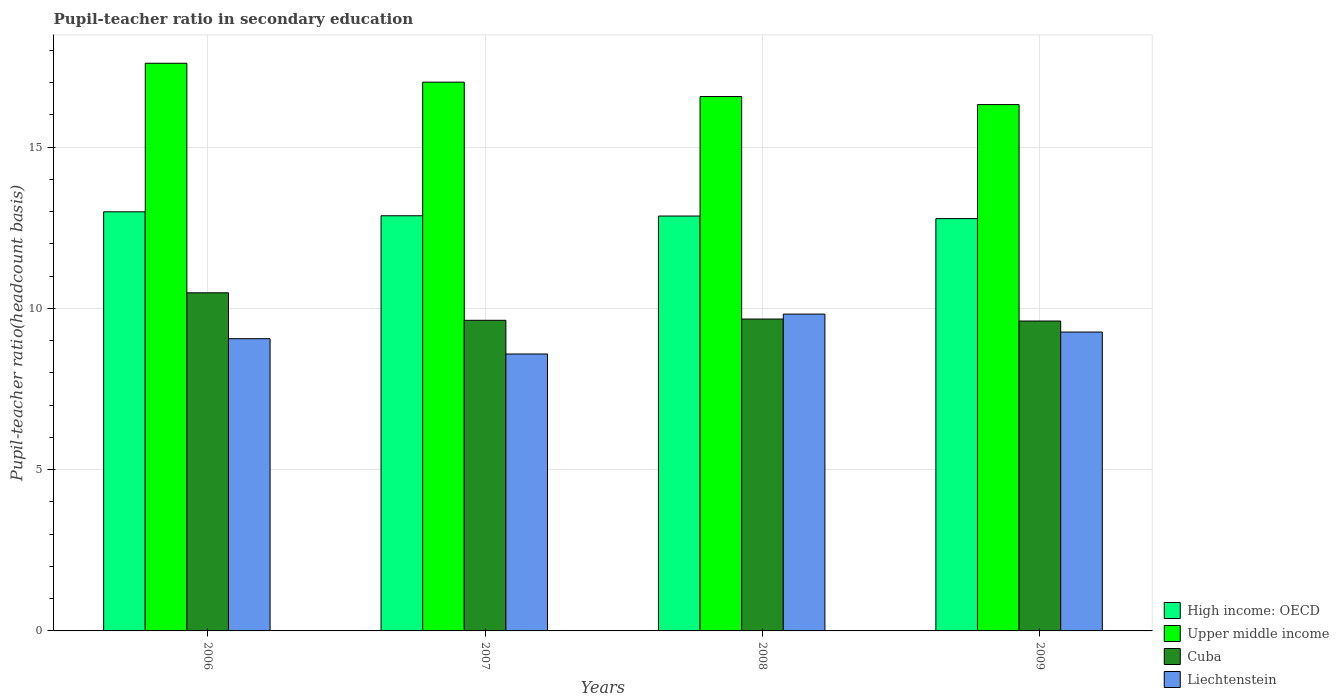Are the number of bars per tick equal to the number of legend labels?
Your answer should be very brief. Yes. How many bars are there on the 4th tick from the left?
Offer a very short reply. 4. How many bars are there on the 2nd tick from the right?
Offer a very short reply. 4. What is the label of the 1st group of bars from the left?
Offer a very short reply. 2006. What is the pupil-teacher ratio in secondary education in Upper middle income in 2006?
Give a very brief answer. 17.6. Across all years, what is the maximum pupil-teacher ratio in secondary education in Liechtenstein?
Give a very brief answer. 9.83. Across all years, what is the minimum pupil-teacher ratio in secondary education in High income: OECD?
Offer a terse response. 12.79. In which year was the pupil-teacher ratio in secondary education in Liechtenstein minimum?
Offer a very short reply. 2007. What is the total pupil-teacher ratio in secondary education in Liechtenstein in the graph?
Make the answer very short. 36.74. What is the difference between the pupil-teacher ratio in secondary education in High income: OECD in 2007 and that in 2008?
Keep it short and to the point. 0.01. What is the difference between the pupil-teacher ratio in secondary education in Liechtenstein in 2007 and the pupil-teacher ratio in secondary education in Cuba in 2006?
Provide a succinct answer. -1.9. What is the average pupil-teacher ratio in secondary education in Cuba per year?
Ensure brevity in your answer.  9.85. In the year 2007, what is the difference between the pupil-teacher ratio in secondary education in Liechtenstein and pupil-teacher ratio in secondary education in Upper middle income?
Ensure brevity in your answer.  -8.43. In how many years, is the pupil-teacher ratio in secondary education in Liechtenstein greater than 2?
Keep it short and to the point. 4. What is the ratio of the pupil-teacher ratio in secondary education in Liechtenstein in 2006 to that in 2008?
Give a very brief answer. 0.92. Is the pupil-teacher ratio in secondary education in Liechtenstein in 2007 less than that in 2008?
Ensure brevity in your answer.  Yes. What is the difference between the highest and the second highest pupil-teacher ratio in secondary education in Upper middle income?
Offer a very short reply. 0.59. What is the difference between the highest and the lowest pupil-teacher ratio in secondary education in Cuba?
Ensure brevity in your answer.  0.87. What does the 2nd bar from the left in 2006 represents?
Your answer should be compact. Upper middle income. What does the 1st bar from the right in 2009 represents?
Provide a short and direct response. Liechtenstein. Is it the case that in every year, the sum of the pupil-teacher ratio in secondary education in Liechtenstein and pupil-teacher ratio in secondary education in Upper middle income is greater than the pupil-teacher ratio in secondary education in High income: OECD?
Provide a succinct answer. Yes. How many bars are there?
Keep it short and to the point. 16. How many years are there in the graph?
Provide a short and direct response. 4. What is the difference between two consecutive major ticks on the Y-axis?
Provide a short and direct response. 5. Are the values on the major ticks of Y-axis written in scientific E-notation?
Provide a succinct answer. No. Does the graph contain grids?
Your answer should be very brief. Yes. How many legend labels are there?
Your answer should be compact. 4. What is the title of the graph?
Give a very brief answer. Pupil-teacher ratio in secondary education. Does "Malawi" appear as one of the legend labels in the graph?
Ensure brevity in your answer.  No. What is the label or title of the X-axis?
Provide a succinct answer. Years. What is the label or title of the Y-axis?
Provide a succinct answer. Pupil-teacher ratio(headcount basis). What is the Pupil-teacher ratio(headcount basis) of High income: OECD in 2006?
Your response must be concise. 13. What is the Pupil-teacher ratio(headcount basis) of Upper middle income in 2006?
Ensure brevity in your answer.  17.6. What is the Pupil-teacher ratio(headcount basis) in Cuba in 2006?
Offer a very short reply. 10.49. What is the Pupil-teacher ratio(headcount basis) in Liechtenstein in 2006?
Provide a short and direct response. 9.06. What is the Pupil-teacher ratio(headcount basis) of High income: OECD in 2007?
Keep it short and to the point. 12.87. What is the Pupil-teacher ratio(headcount basis) of Upper middle income in 2007?
Ensure brevity in your answer.  17.02. What is the Pupil-teacher ratio(headcount basis) in Cuba in 2007?
Offer a very short reply. 9.63. What is the Pupil-teacher ratio(headcount basis) of Liechtenstein in 2007?
Provide a short and direct response. 8.59. What is the Pupil-teacher ratio(headcount basis) in High income: OECD in 2008?
Your answer should be compact. 12.87. What is the Pupil-teacher ratio(headcount basis) of Upper middle income in 2008?
Provide a short and direct response. 16.57. What is the Pupil-teacher ratio(headcount basis) in Cuba in 2008?
Provide a succinct answer. 9.67. What is the Pupil-teacher ratio(headcount basis) of Liechtenstein in 2008?
Your answer should be very brief. 9.83. What is the Pupil-teacher ratio(headcount basis) in High income: OECD in 2009?
Your answer should be compact. 12.79. What is the Pupil-teacher ratio(headcount basis) of Upper middle income in 2009?
Ensure brevity in your answer.  16.32. What is the Pupil-teacher ratio(headcount basis) of Cuba in 2009?
Your answer should be very brief. 9.61. What is the Pupil-teacher ratio(headcount basis) in Liechtenstein in 2009?
Ensure brevity in your answer.  9.27. Across all years, what is the maximum Pupil-teacher ratio(headcount basis) in High income: OECD?
Offer a very short reply. 13. Across all years, what is the maximum Pupil-teacher ratio(headcount basis) in Upper middle income?
Give a very brief answer. 17.6. Across all years, what is the maximum Pupil-teacher ratio(headcount basis) in Cuba?
Your answer should be compact. 10.49. Across all years, what is the maximum Pupil-teacher ratio(headcount basis) in Liechtenstein?
Your answer should be compact. 9.83. Across all years, what is the minimum Pupil-teacher ratio(headcount basis) in High income: OECD?
Offer a very short reply. 12.79. Across all years, what is the minimum Pupil-teacher ratio(headcount basis) of Upper middle income?
Provide a short and direct response. 16.32. Across all years, what is the minimum Pupil-teacher ratio(headcount basis) in Cuba?
Provide a short and direct response. 9.61. Across all years, what is the minimum Pupil-teacher ratio(headcount basis) in Liechtenstein?
Ensure brevity in your answer.  8.59. What is the total Pupil-teacher ratio(headcount basis) in High income: OECD in the graph?
Provide a succinct answer. 51.52. What is the total Pupil-teacher ratio(headcount basis) of Upper middle income in the graph?
Provide a succinct answer. 67.52. What is the total Pupil-teacher ratio(headcount basis) of Cuba in the graph?
Provide a short and direct response. 39.4. What is the total Pupil-teacher ratio(headcount basis) of Liechtenstein in the graph?
Ensure brevity in your answer.  36.74. What is the difference between the Pupil-teacher ratio(headcount basis) of High income: OECD in 2006 and that in 2007?
Your answer should be very brief. 0.12. What is the difference between the Pupil-teacher ratio(headcount basis) in Upper middle income in 2006 and that in 2007?
Give a very brief answer. 0.59. What is the difference between the Pupil-teacher ratio(headcount basis) of Cuba in 2006 and that in 2007?
Your response must be concise. 0.85. What is the difference between the Pupil-teacher ratio(headcount basis) of Liechtenstein in 2006 and that in 2007?
Your answer should be very brief. 0.47. What is the difference between the Pupil-teacher ratio(headcount basis) in High income: OECD in 2006 and that in 2008?
Provide a succinct answer. 0.13. What is the difference between the Pupil-teacher ratio(headcount basis) in Upper middle income in 2006 and that in 2008?
Provide a succinct answer. 1.03. What is the difference between the Pupil-teacher ratio(headcount basis) of Cuba in 2006 and that in 2008?
Give a very brief answer. 0.81. What is the difference between the Pupil-teacher ratio(headcount basis) in Liechtenstein in 2006 and that in 2008?
Provide a short and direct response. -0.76. What is the difference between the Pupil-teacher ratio(headcount basis) in High income: OECD in 2006 and that in 2009?
Keep it short and to the point. 0.21. What is the difference between the Pupil-teacher ratio(headcount basis) of Upper middle income in 2006 and that in 2009?
Your answer should be very brief. 1.28. What is the difference between the Pupil-teacher ratio(headcount basis) of Liechtenstein in 2006 and that in 2009?
Your response must be concise. -0.21. What is the difference between the Pupil-teacher ratio(headcount basis) in High income: OECD in 2007 and that in 2008?
Give a very brief answer. 0.01. What is the difference between the Pupil-teacher ratio(headcount basis) of Upper middle income in 2007 and that in 2008?
Keep it short and to the point. 0.45. What is the difference between the Pupil-teacher ratio(headcount basis) in Cuba in 2007 and that in 2008?
Ensure brevity in your answer.  -0.04. What is the difference between the Pupil-teacher ratio(headcount basis) of Liechtenstein in 2007 and that in 2008?
Your response must be concise. -1.24. What is the difference between the Pupil-teacher ratio(headcount basis) in High income: OECD in 2007 and that in 2009?
Your response must be concise. 0.09. What is the difference between the Pupil-teacher ratio(headcount basis) in Upper middle income in 2007 and that in 2009?
Give a very brief answer. 0.7. What is the difference between the Pupil-teacher ratio(headcount basis) of Cuba in 2007 and that in 2009?
Keep it short and to the point. 0.02. What is the difference between the Pupil-teacher ratio(headcount basis) in Liechtenstein in 2007 and that in 2009?
Offer a very short reply. -0.68. What is the difference between the Pupil-teacher ratio(headcount basis) of High income: OECD in 2008 and that in 2009?
Offer a very short reply. 0.08. What is the difference between the Pupil-teacher ratio(headcount basis) of Upper middle income in 2008 and that in 2009?
Your response must be concise. 0.25. What is the difference between the Pupil-teacher ratio(headcount basis) of Cuba in 2008 and that in 2009?
Your response must be concise. 0.06. What is the difference between the Pupil-teacher ratio(headcount basis) of Liechtenstein in 2008 and that in 2009?
Give a very brief answer. 0.56. What is the difference between the Pupil-teacher ratio(headcount basis) in High income: OECD in 2006 and the Pupil-teacher ratio(headcount basis) in Upper middle income in 2007?
Give a very brief answer. -4.02. What is the difference between the Pupil-teacher ratio(headcount basis) in High income: OECD in 2006 and the Pupil-teacher ratio(headcount basis) in Cuba in 2007?
Your answer should be compact. 3.37. What is the difference between the Pupil-teacher ratio(headcount basis) in High income: OECD in 2006 and the Pupil-teacher ratio(headcount basis) in Liechtenstein in 2007?
Offer a terse response. 4.41. What is the difference between the Pupil-teacher ratio(headcount basis) in Upper middle income in 2006 and the Pupil-teacher ratio(headcount basis) in Cuba in 2007?
Give a very brief answer. 7.97. What is the difference between the Pupil-teacher ratio(headcount basis) in Upper middle income in 2006 and the Pupil-teacher ratio(headcount basis) in Liechtenstein in 2007?
Your answer should be compact. 9.02. What is the difference between the Pupil-teacher ratio(headcount basis) of Cuba in 2006 and the Pupil-teacher ratio(headcount basis) of Liechtenstein in 2007?
Offer a terse response. 1.9. What is the difference between the Pupil-teacher ratio(headcount basis) of High income: OECD in 2006 and the Pupil-teacher ratio(headcount basis) of Upper middle income in 2008?
Offer a terse response. -3.57. What is the difference between the Pupil-teacher ratio(headcount basis) of High income: OECD in 2006 and the Pupil-teacher ratio(headcount basis) of Cuba in 2008?
Provide a succinct answer. 3.33. What is the difference between the Pupil-teacher ratio(headcount basis) of High income: OECD in 2006 and the Pupil-teacher ratio(headcount basis) of Liechtenstein in 2008?
Your answer should be compact. 3.17. What is the difference between the Pupil-teacher ratio(headcount basis) in Upper middle income in 2006 and the Pupil-teacher ratio(headcount basis) in Cuba in 2008?
Keep it short and to the point. 7.93. What is the difference between the Pupil-teacher ratio(headcount basis) of Upper middle income in 2006 and the Pupil-teacher ratio(headcount basis) of Liechtenstein in 2008?
Your answer should be compact. 7.78. What is the difference between the Pupil-teacher ratio(headcount basis) of Cuba in 2006 and the Pupil-teacher ratio(headcount basis) of Liechtenstein in 2008?
Give a very brief answer. 0.66. What is the difference between the Pupil-teacher ratio(headcount basis) in High income: OECD in 2006 and the Pupil-teacher ratio(headcount basis) in Upper middle income in 2009?
Make the answer very short. -3.32. What is the difference between the Pupil-teacher ratio(headcount basis) in High income: OECD in 2006 and the Pupil-teacher ratio(headcount basis) in Cuba in 2009?
Your answer should be very brief. 3.39. What is the difference between the Pupil-teacher ratio(headcount basis) in High income: OECD in 2006 and the Pupil-teacher ratio(headcount basis) in Liechtenstein in 2009?
Make the answer very short. 3.73. What is the difference between the Pupil-teacher ratio(headcount basis) of Upper middle income in 2006 and the Pupil-teacher ratio(headcount basis) of Cuba in 2009?
Provide a succinct answer. 7.99. What is the difference between the Pupil-teacher ratio(headcount basis) of Upper middle income in 2006 and the Pupil-teacher ratio(headcount basis) of Liechtenstein in 2009?
Your answer should be very brief. 8.34. What is the difference between the Pupil-teacher ratio(headcount basis) of Cuba in 2006 and the Pupil-teacher ratio(headcount basis) of Liechtenstein in 2009?
Give a very brief answer. 1.22. What is the difference between the Pupil-teacher ratio(headcount basis) in High income: OECD in 2007 and the Pupil-teacher ratio(headcount basis) in Upper middle income in 2008?
Ensure brevity in your answer.  -3.7. What is the difference between the Pupil-teacher ratio(headcount basis) in High income: OECD in 2007 and the Pupil-teacher ratio(headcount basis) in Cuba in 2008?
Ensure brevity in your answer.  3.2. What is the difference between the Pupil-teacher ratio(headcount basis) in High income: OECD in 2007 and the Pupil-teacher ratio(headcount basis) in Liechtenstein in 2008?
Provide a short and direct response. 3.05. What is the difference between the Pupil-teacher ratio(headcount basis) of Upper middle income in 2007 and the Pupil-teacher ratio(headcount basis) of Cuba in 2008?
Your answer should be compact. 7.35. What is the difference between the Pupil-teacher ratio(headcount basis) of Upper middle income in 2007 and the Pupil-teacher ratio(headcount basis) of Liechtenstein in 2008?
Ensure brevity in your answer.  7.19. What is the difference between the Pupil-teacher ratio(headcount basis) of Cuba in 2007 and the Pupil-teacher ratio(headcount basis) of Liechtenstein in 2008?
Offer a terse response. -0.19. What is the difference between the Pupil-teacher ratio(headcount basis) in High income: OECD in 2007 and the Pupil-teacher ratio(headcount basis) in Upper middle income in 2009?
Your answer should be compact. -3.45. What is the difference between the Pupil-teacher ratio(headcount basis) in High income: OECD in 2007 and the Pupil-teacher ratio(headcount basis) in Cuba in 2009?
Your answer should be very brief. 3.26. What is the difference between the Pupil-teacher ratio(headcount basis) of High income: OECD in 2007 and the Pupil-teacher ratio(headcount basis) of Liechtenstein in 2009?
Offer a terse response. 3.61. What is the difference between the Pupil-teacher ratio(headcount basis) of Upper middle income in 2007 and the Pupil-teacher ratio(headcount basis) of Cuba in 2009?
Make the answer very short. 7.41. What is the difference between the Pupil-teacher ratio(headcount basis) of Upper middle income in 2007 and the Pupil-teacher ratio(headcount basis) of Liechtenstein in 2009?
Provide a succinct answer. 7.75. What is the difference between the Pupil-teacher ratio(headcount basis) in Cuba in 2007 and the Pupil-teacher ratio(headcount basis) in Liechtenstein in 2009?
Offer a terse response. 0.36. What is the difference between the Pupil-teacher ratio(headcount basis) of High income: OECD in 2008 and the Pupil-teacher ratio(headcount basis) of Upper middle income in 2009?
Offer a very short reply. -3.46. What is the difference between the Pupil-teacher ratio(headcount basis) of High income: OECD in 2008 and the Pupil-teacher ratio(headcount basis) of Cuba in 2009?
Make the answer very short. 3.26. What is the difference between the Pupil-teacher ratio(headcount basis) of High income: OECD in 2008 and the Pupil-teacher ratio(headcount basis) of Liechtenstein in 2009?
Offer a very short reply. 3.6. What is the difference between the Pupil-teacher ratio(headcount basis) of Upper middle income in 2008 and the Pupil-teacher ratio(headcount basis) of Cuba in 2009?
Make the answer very short. 6.96. What is the difference between the Pupil-teacher ratio(headcount basis) of Upper middle income in 2008 and the Pupil-teacher ratio(headcount basis) of Liechtenstein in 2009?
Provide a succinct answer. 7.3. What is the difference between the Pupil-teacher ratio(headcount basis) of Cuba in 2008 and the Pupil-teacher ratio(headcount basis) of Liechtenstein in 2009?
Keep it short and to the point. 0.4. What is the average Pupil-teacher ratio(headcount basis) of High income: OECD per year?
Provide a succinct answer. 12.88. What is the average Pupil-teacher ratio(headcount basis) in Upper middle income per year?
Make the answer very short. 16.88. What is the average Pupil-teacher ratio(headcount basis) in Cuba per year?
Provide a short and direct response. 9.85. What is the average Pupil-teacher ratio(headcount basis) in Liechtenstein per year?
Offer a terse response. 9.19. In the year 2006, what is the difference between the Pupil-teacher ratio(headcount basis) in High income: OECD and Pupil-teacher ratio(headcount basis) in Upper middle income?
Make the answer very short. -4.61. In the year 2006, what is the difference between the Pupil-teacher ratio(headcount basis) of High income: OECD and Pupil-teacher ratio(headcount basis) of Cuba?
Offer a terse response. 2.51. In the year 2006, what is the difference between the Pupil-teacher ratio(headcount basis) in High income: OECD and Pupil-teacher ratio(headcount basis) in Liechtenstein?
Ensure brevity in your answer.  3.94. In the year 2006, what is the difference between the Pupil-teacher ratio(headcount basis) in Upper middle income and Pupil-teacher ratio(headcount basis) in Cuba?
Give a very brief answer. 7.12. In the year 2006, what is the difference between the Pupil-teacher ratio(headcount basis) of Upper middle income and Pupil-teacher ratio(headcount basis) of Liechtenstein?
Ensure brevity in your answer.  8.54. In the year 2006, what is the difference between the Pupil-teacher ratio(headcount basis) in Cuba and Pupil-teacher ratio(headcount basis) in Liechtenstein?
Your response must be concise. 1.42. In the year 2007, what is the difference between the Pupil-teacher ratio(headcount basis) in High income: OECD and Pupil-teacher ratio(headcount basis) in Upper middle income?
Your response must be concise. -4.14. In the year 2007, what is the difference between the Pupil-teacher ratio(headcount basis) of High income: OECD and Pupil-teacher ratio(headcount basis) of Cuba?
Give a very brief answer. 3.24. In the year 2007, what is the difference between the Pupil-teacher ratio(headcount basis) of High income: OECD and Pupil-teacher ratio(headcount basis) of Liechtenstein?
Your answer should be very brief. 4.29. In the year 2007, what is the difference between the Pupil-teacher ratio(headcount basis) of Upper middle income and Pupil-teacher ratio(headcount basis) of Cuba?
Your answer should be very brief. 7.39. In the year 2007, what is the difference between the Pupil-teacher ratio(headcount basis) of Upper middle income and Pupil-teacher ratio(headcount basis) of Liechtenstein?
Provide a succinct answer. 8.43. In the year 2007, what is the difference between the Pupil-teacher ratio(headcount basis) in Cuba and Pupil-teacher ratio(headcount basis) in Liechtenstein?
Make the answer very short. 1.04. In the year 2008, what is the difference between the Pupil-teacher ratio(headcount basis) in High income: OECD and Pupil-teacher ratio(headcount basis) in Upper middle income?
Your answer should be very brief. -3.71. In the year 2008, what is the difference between the Pupil-teacher ratio(headcount basis) of High income: OECD and Pupil-teacher ratio(headcount basis) of Cuba?
Ensure brevity in your answer.  3.19. In the year 2008, what is the difference between the Pupil-teacher ratio(headcount basis) in High income: OECD and Pupil-teacher ratio(headcount basis) in Liechtenstein?
Provide a succinct answer. 3.04. In the year 2008, what is the difference between the Pupil-teacher ratio(headcount basis) of Upper middle income and Pupil-teacher ratio(headcount basis) of Liechtenstein?
Provide a short and direct response. 6.75. In the year 2008, what is the difference between the Pupil-teacher ratio(headcount basis) of Cuba and Pupil-teacher ratio(headcount basis) of Liechtenstein?
Keep it short and to the point. -0.15. In the year 2009, what is the difference between the Pupil-teacher ratio(headcount basis) of High income: OECD and Pupil-teacher ratio(headcount basis) of Upper middle income?
Ensure brevity in your answer.  -3.54. In the year 2009, what is the difference between the Pupil-teacher ratio(headcount basis) in High income: OECD and Pupil-teacher ratio(headcount basis) in Cuba?
Provide a short and direct response. 3.18. In the year 2009, what is the difference between the Pupil-teacher ratio(headcount basis) of High income: OECD and Pupil-teacher ratio(headcount basis) of Liechtenstein?
Keep it short and to the point. 3.52. In the year 2009, what is the difference between the Pupil-teacher ratio(headcount basis) in Upper middle income and Pupil-teacher ratio(headcount basis) in Cuba?
Provide a short and direct response. 6.71. In the year 2009, what is the difference between the Pupil-teacher ratio(headcount basis) of Upper middle income and Pupil-teacher ratio(headcount basis) of Liechtenstein?
Offer a very short reply. 7.05. In the year 2009, what is the difference between the Pupil-teacher ratio(headcount basis) in Cuba and Pupil-teacher ratio(headcount basis) in Liechtenstein?
Provide a succinct answer. 0.34. What is the ratio of the Pupil-teacher ratio(headcount basis) in High income: OECD in 2006 to that in 2007?
Your response must be concise. 1.01. What is the ratio of the Pupil-teacher ratio(headcount basis) of Upper middle income in 2006 to that in 2007?
Make the answer very short. 1.03. What is the ratio of the Pupil-teacher ratio(headcount basis) in Cuba in 2006 to that in 2007?
Provide a short and direct response. 1.09. What is the ratio of the Pupil-teacher ratio(headcount basis) in Liechtenstein in 2006 to that in 2007?
Provide a short and direct response. 1.06. What is the ratio of the Pupil-teacher ratio(headcount basis) of High income: OECD in 2006 to that in 2008?
Your response must be concise. 1.01. What is the ratio of the Pupil-teacher ratio(headcount basis) in Upper middle income in 2006 to that in 2008?
Your answer should be compact. 1.06. What is the ratio of the Pupil-teacher ratio(headcount basis) in Cuba in 2006 to that in 2008?
Make the answer very short. 1.08. What is the ratio of the Pupil-teacher ratio(headcount basis) in Liechtenstein in 2006 to that in 2008?
Ensure brevity in your answer.  0.92. What is the ratio of the Pupil-teacher ratio(headcount basis) in High income: OECD in 2006 to that in 2009?
Offer a very short reply. 1.02. What is the ratio of the Pupil-teacher ratio(headcount basis) of Upper middle income in 2006 to that in 2009?
Offer a very short reply. 1.08. What is the ratio of the Pupil-teacher ratio(headcount basis) in Cuba in 2006 to that in 2009?
Give a very brief answer. 1.09. What is the ratio of the Pupil-teacher ratio(headcount basis) of Liechtenstein in 2006 to that in 2009?
Provide a short and direct response. 0.98. What is the ratio of the Pupil-teacher ratio(headcount basis) of Upper middle income in 2007 to that in 2008?
Give a very brief answer. 1.03. What is the ratio of the Pupil-teacher ratio(headcount basis) of Liechtenstein in 2007 to that in 2008?
Your response must be concise. 0.87. What is the ratio of the Pupil-teacher ratio(headcount basis) of Upper middle income in 2007 to that in 2009?
Provide a short and direct response. 1.04. What is the ratio of the Pupil-teacher ratio(headcount basis) of Cuba in 2007 to that in 2009?
Give a very brief answer. 1. What is the ratio of the Pupil-teacher ratio(headcount basis) in Liechtenstein in 2007 to that in 2009?
Keep it short and to the point. 0.93. What is the ratio of the Pupil-teacher ratio(headcount basis) in High income: OECD in 2008 to that in 2009?
Give a very brief answer. 1.01. What is the ratio of the Pupil-teacher ratio(headcount basis) in Upper middle income in 2008 to that in 2009?
Ensure brevity in your answer.  1.02. What is the ratio of the Pupil-teacher ratio(headcount basis) in Cuba in 2008 to that in 2009?
Ensure brevity in your answer.  1.01. What is the ratio of the Pupil-teacher ratio(headcount basis) of Liechtenstein in 2008 to that in 2009?
Your answer should be very brief. 1.06. What is the difference between the highest and the second highest Pupil-teacher ratio(headcount basis) of High income: OECD?
Keep it short and to the point. 0.12. What is the difference between the highest and the second highest Pupil-teacher ratio(headcount basis) of Upper middle income?
Your answer should be compact. 0.59. What is the difference between the highest and the second highest Pupil-teacher ratio(headcount basis) in Cuba?
Your answer should be compact. 0.81. What is the difference between the highest and the second highest Pupil-teacher ratio(headcount basis) of Liechtenstein?
Your answer should be very brief. 0.56. What is the difference between the highest and the lowest Pupil-teacher ratio(headcount basis) of High income: OECD?
Make the answer very short. 0.21. What is the difference between the highest and the lowest Pupil-teacher ratio(headcount basis) in Upper middle income?
Provide a succinct answer. 1.28. What is the difference between the highest and the lowest Pupil-teacher ratio(headcount basis) in Cuba?
Make the answer very short. 0.88. What is the difference between the highest and the lowest Pupil-teacher ratio(headcount basis) of Liechtenstein?
Offer a terse response. 1.24. 